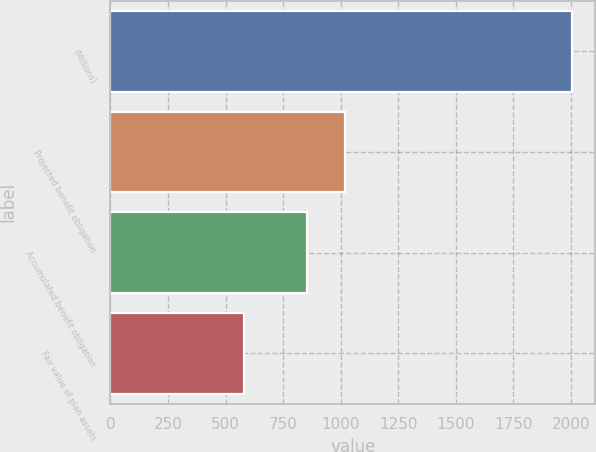<chart> <loc_0><loc_0><loc_500><loc_500><bar_chart><fcel>(Millions)<fcel>Projected benefit obligation<fcel>Accumulated benefit obligation<fcel>Fair value of plan assets<nl><fcel>2006<fcel>1020<fcel>854<fcel>578<nl></chart> 